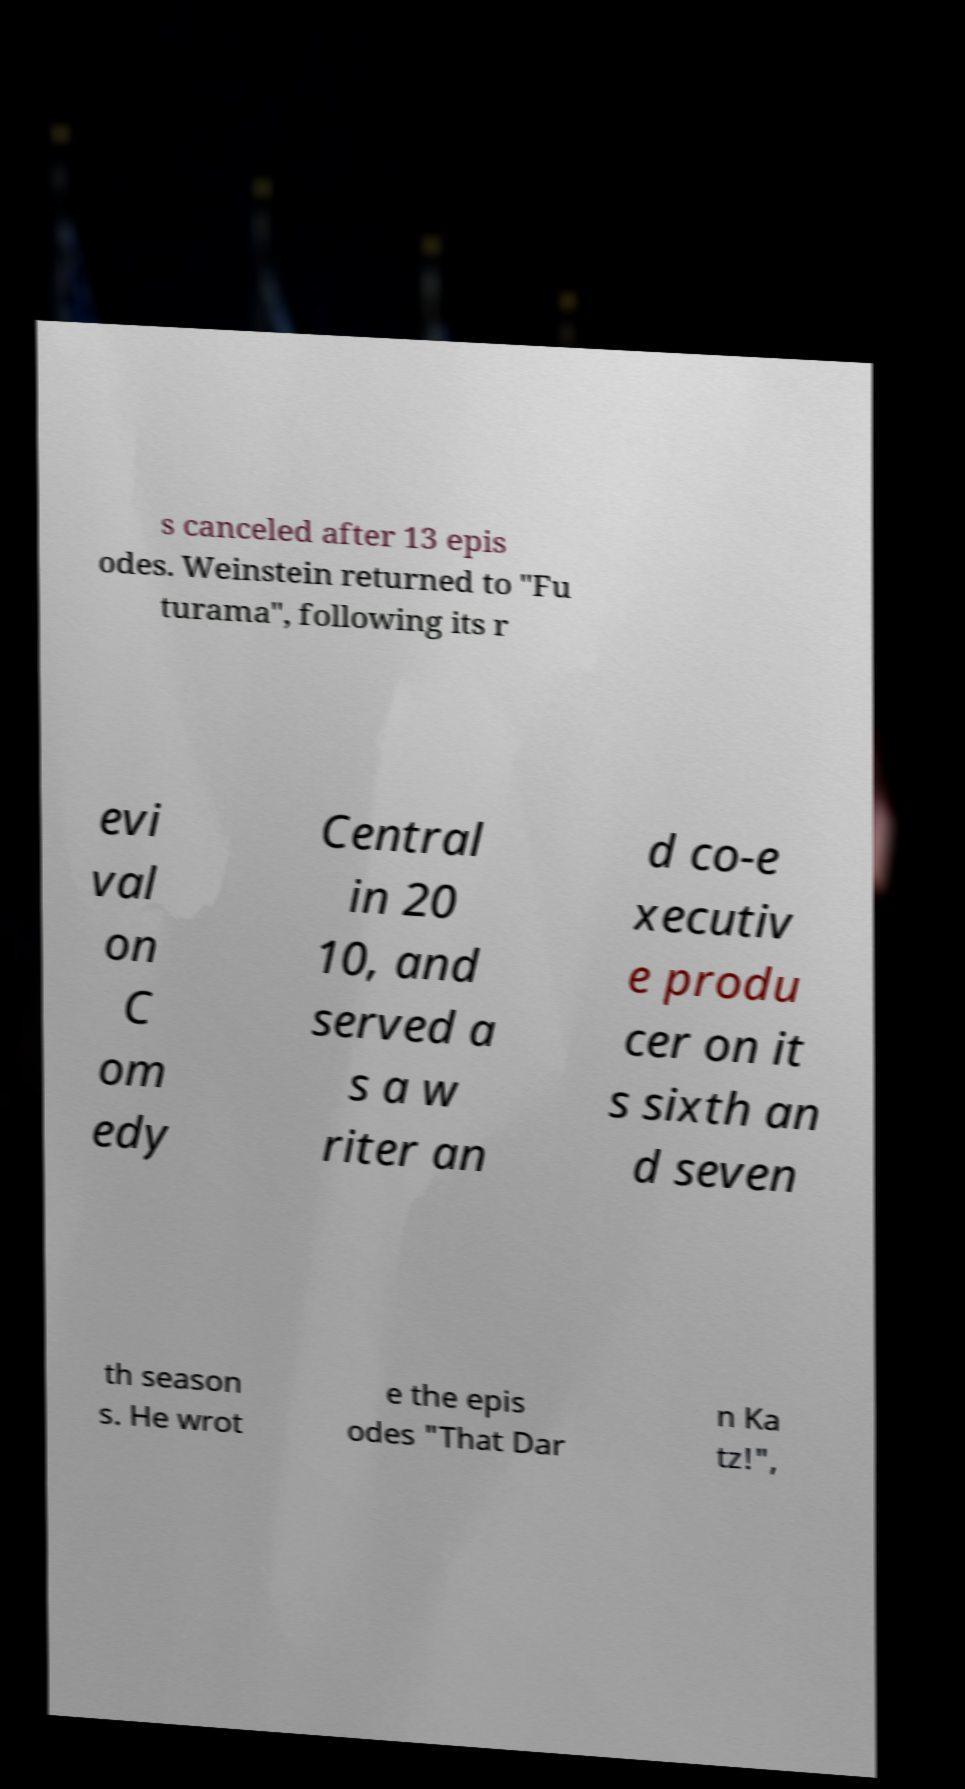Can you accurately transcribe the text from the provided image for me? s canceled after 13 epis odes. Weinstein returned to "Fu turama", following its r evi val on C om edy Central in 20 10, and served a s a w riter an d co-e xecutiv e produ cer on it s sixth an d seven th season s. He wrot e the epis odes "That Dar n Ka tz!", 